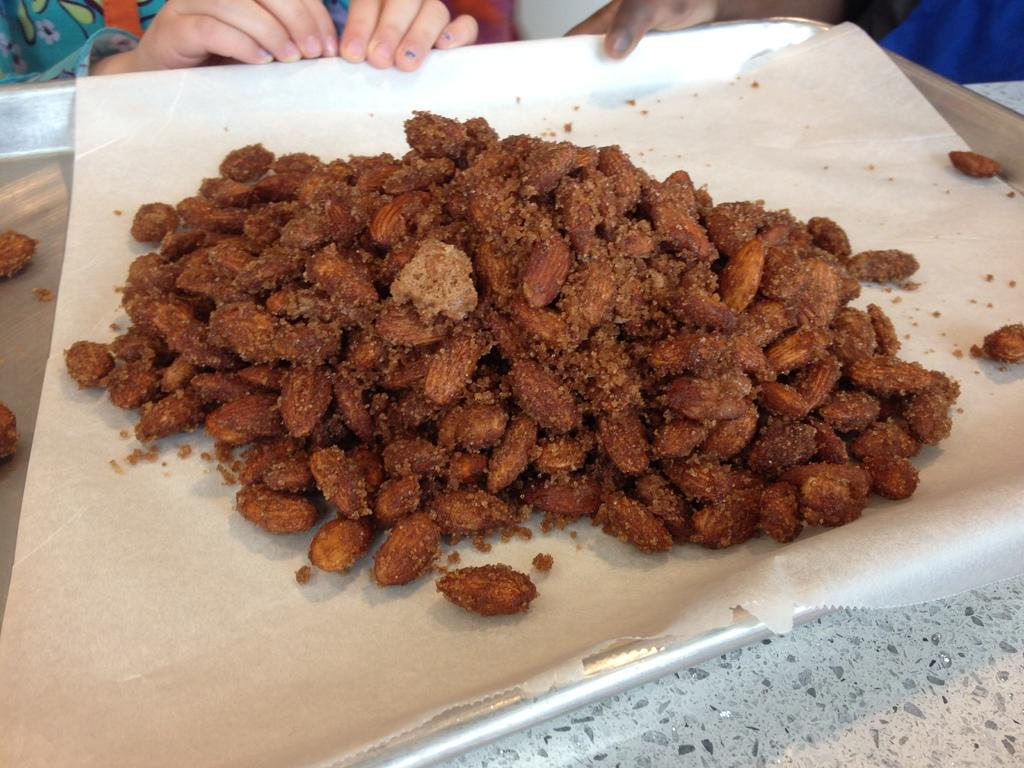What is on the paper that is visible in the image? There are roasted almonds on the paper. Where is the paper located in the image? The paper is on a tray. Can you describe the people in the image? The people in the image are wearing clothes. What type of egg is being sold in the shop in the image? There is no shop or egg present in the image. Can you see any twigs in the image? There are no twigs visible in the image. 